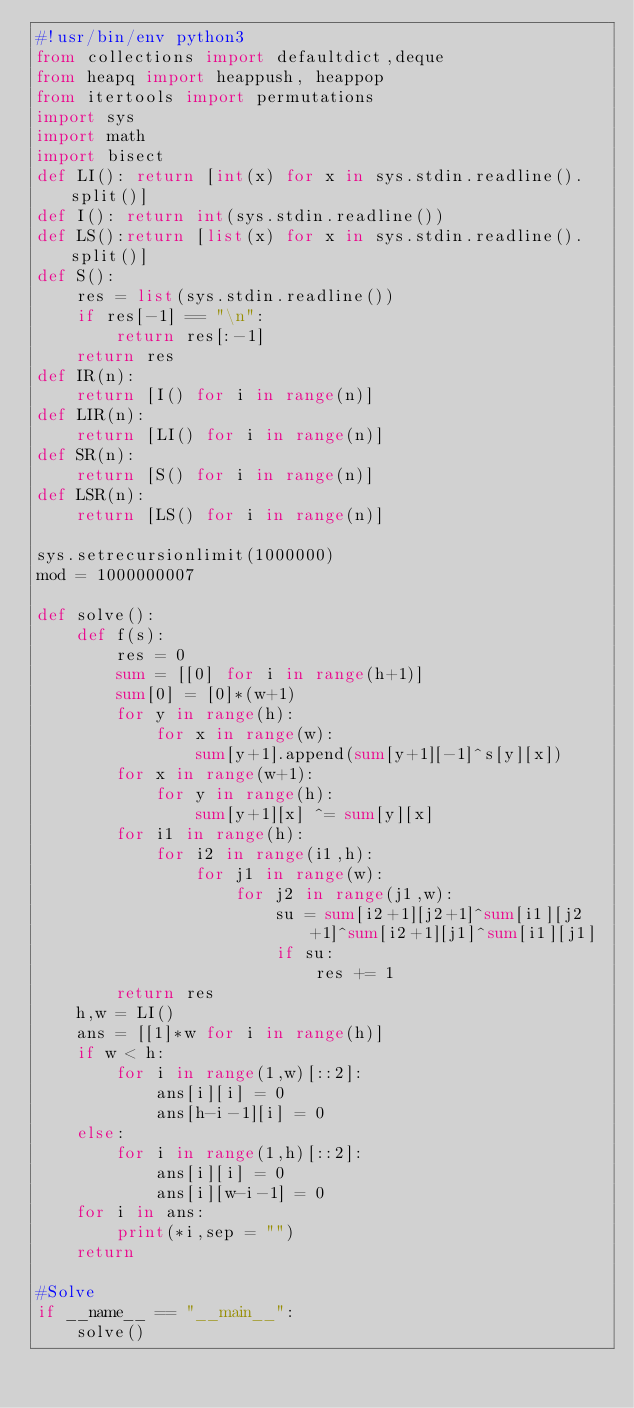<code> <loc_0><loc_0><loc_500><loc_500><_Python_>#!usr/bin/env python3
from collections import defaultdict,deque
from heapq import heappush, heappop
from itertools import permutations
import sys
import math
import bisect
def LI(): return [int(x) for x in sys.stdin.readline().split()]
def I(): return int(sys.stdin.readline())
def LS():return [list(x) for x in sys.stdin.readline().split()]
def S():
    res = list(sys.stdin.readline())
    if res[-1] == "\n":
        return res[:-1]
    return res
def IR(n):
    return [I() for i in range(n)]
def LIR(n):
    return [LI() for i in range(n)]
def SR(n):
    return [S() for i in range(n)]
def LSR(n):
    return [LS() for i in range(n)]

sys.setrecursionlimit(1000000)
mod = 1000000007

def solve():
    def f(s):
        res = 0
        sum = [[0] for i in range(h+1)]
        sum[0] = [0]*(w+1)
        for y in range(h):
            for x in range(w):
                sum[y+1].append(sum[y+1][-1]^s[y][x])
        for x in range(w+1):
            for y in range(h):
                sum[y+1][x] ^= sum[y][x]
        for i1 in range(h):
            for i2 in range(i1,h):
                for j1 in range(w):
                    for j2 in range(j1,w):
                        su = sum[i2+1][j2+1]^sum[i1][j2+1]^sum[i2+1][j1]^sum[i1][j1]
                        if su:
                            res += 1
        return res
    h,w = LI()
    ans = [[1]*w for i in range(h)]
    if w < h:
        for i in range(1,w)[::2]:
            ans[i][i] = 0
            ans[h-i-1][i] = 0
    else:
        for i in range(1,h)[::2]:
            ans[i][i] = 0
            ans[i][w-i-1] = 0
    for i in ans:
        print(*i,sep = "")
    return

#Solve
if __name__ == "__main__":
    solve()
</code> 